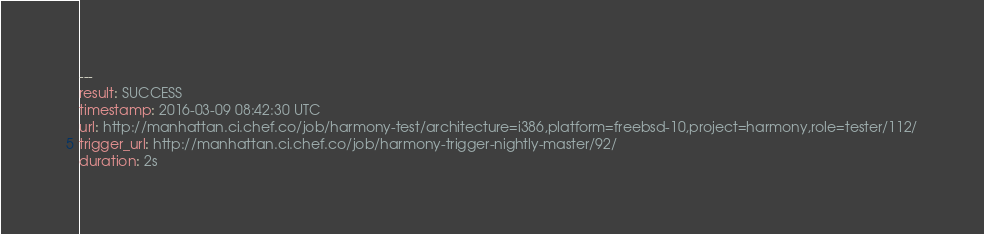Convert code to text. <code><loc_0><loc_0><loc_500><loc_500><_YAML_>---
result: SUCCESS
timestamp: 2016-03-09 08:42:30 UTC
url: http://manhattan.ci.chef.co/job/harmony-test/architecture=i386,platform=freebsd-10,project=harmony,role=tester/112/
trigger_url: http://manhattan.ci.chef.co/job/harmony-trigger-nightly-master/92/
duration: 2s
</code> 